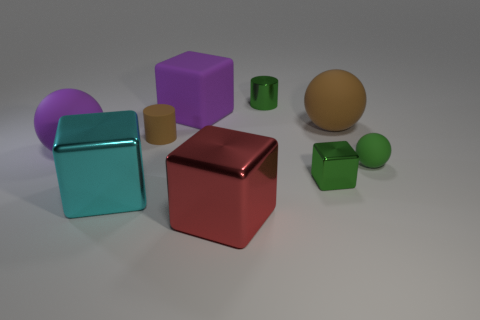Can you tell me the colors of the objects starting from the one closest to the camera? Certainly! Starting from the object closest to the camera: the cube is red, the next cube is aqua blue, followed by a purple cube, a green cube, a light brown cylinder, a beige sphere, a green sphere, and finally a small yellow cylinder. 